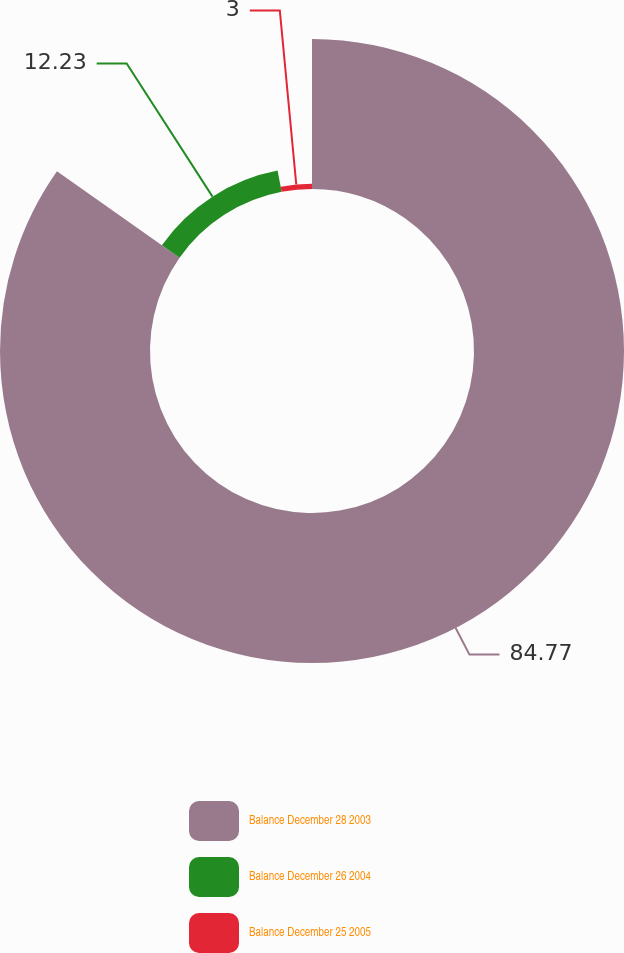Convert chart to OTSL. <chart><loc_0><loc_0><loc_500><loc_500><pie_chart><fcel>Balance December 28 2003<fcel>Balance December 26 2004<fcel>Balance December 25 2005<nl><fcel>84.77%<fcel>12.23%<fcel>3.0%<nl></chart> 